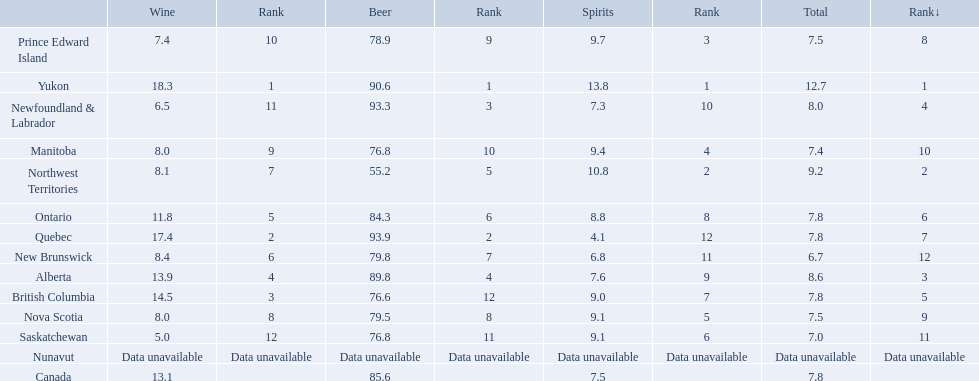What are all the canadian regions? Yukon, Northwest Territories, Alberta, Newfoundland & Labrador, British Columbia, Ontario, Quebec, Prince Edward Island, Nova Scotia, Manitoba, Saskatchewan, New Brunswick, Nunavut, Canada. What was the spirits consumption? 13.8, 10.8, 7.6, 7.3, 9.0, 8.8, 4.1, 9.7, 9.1, 9.4, 9.1, 6.8, Data unavailable, 7.5. What was quebec's spirit consumption? 4.1. 